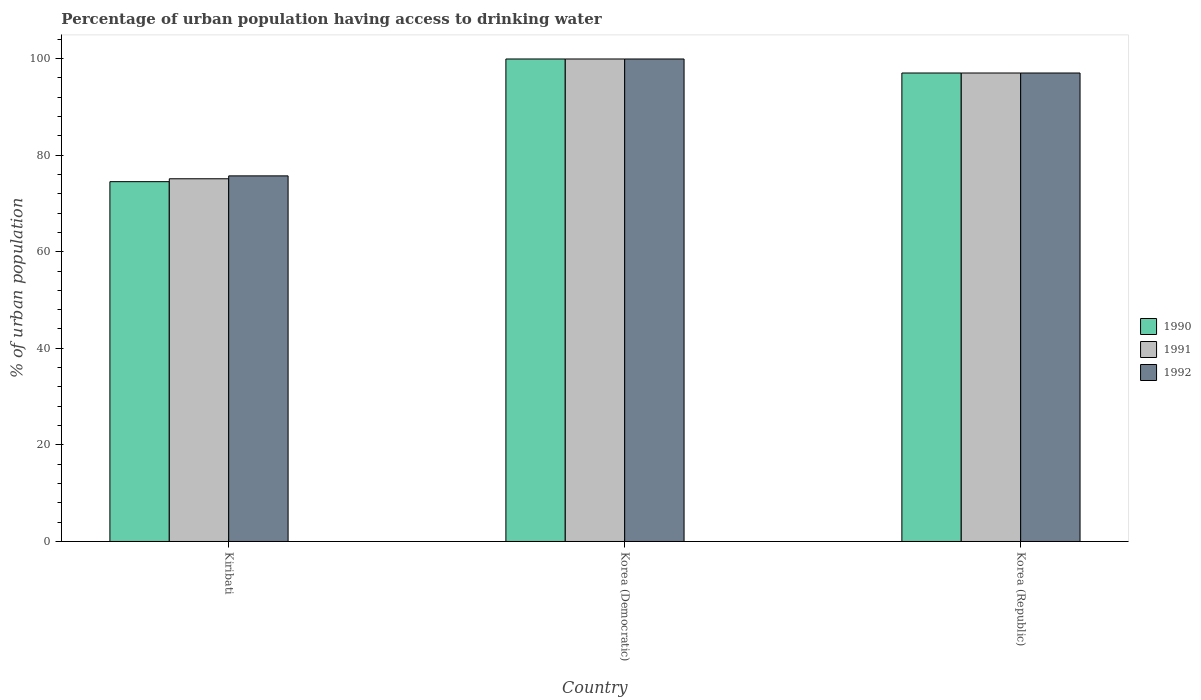How many different coloured bars are there?
Offer a very short reply. 3. How many groups of bars are there?
Keep it short and to the point. 3. Are the number of bars on each tick of the X-axis equal?
Your response must be concise. Yes. How many bars are there on the 1st tick from the left?
Make the answer very short. 3. How many bars are there on the 3rd tick from the right?
Offer a very short reply. 3. In how many cases, is the number of bars for a given country not equal to the number of legend labels?
Provide a succinct answer. 0. What is the percentage of urban population having access to drinking water in 1990 in Korea (Republic)?
Your answer should be compact. 97. Across all countries, what is the maximum percentage of urban population having access to drinking water in 1990?
Ensure brevity in your answer.  99.9. Across all countries, what is the minimum percentage of urban population having access to drinking water in 1990?
Make the answer very short. 74.5. In which country was the percentage of urban population having access to drinking water in 1992 maximum?
Your answer should be very brief. Korea (Democratic). In which country was the percentage of urban population having access to drinking water in 1991 minimum?
Keep it short and to the point. Kiribati. What is the total percentage of urban population having access to drinking water in 1992 in the graph?
Keep it short and to the point. 272.6. What is the difference between the percentage of urban population having access to drinking water in 1992 in Korea (Democratic) and that in Korea (Republic)?
Offer a terse response. 2.9. What is the difference between the percentage of urban population having access to drinking water in 1990 in Korea (Democratic) and the percentage of urban population having access to drinking water in 1991 in Korea (Republic)?
Provide a short and direct response. 2.9. What is the average percentage of urban population having access to drinking water in 1990 per country?
Provide a succinct answer. 90.47. What is the difference between the percentage of urban population having access to drinking water of/in 1991 and percentage of urban population having access to drinking water of/in 1990 in Korea (Republic)?
Ensure brevity in your answer.  0. What is the ratio of the percentage of urban population having access to drinking water in 1990 in Korea (Democratic) to that in Korea (Republic)?
Make the answer very short. 1.03. Is the percentage of urban population having access to drinking water in 1990 in Kiribati less than that in Korea (Democratic)?
Give a very brief answer. Yes. What is the difference between the highest and the second highest percentage of urban population having access to drinking water in 1990?
Offer a very short reply. 22.5. What is the difference between the highest and the lowest percentage of urban population having access to drinking water in 1991?
Your answer should be very brief. 24.8. In how many countries, is the percentage of urban population having access to drinking water in 1992 greater than the average percentage of urban population having access to drinking water in 1992 taken over all countries?
Offer a terse response. 2. Is the sum of the percentage of urban population having access to drinking water in 1990 in Kiribati and Korea (Democratic) greater than the maximum percentage of urban population having access to drinking water in 1992 across all countries?
Offer a terse response. Yes. Are all the bars in the graph horizontal?
Make the answer very short. No. How many countries are there in the graph?
Provide a succinct answer. 3. What is the difference between two consecutive major ticks on the Y-axis?
Your response must be concise. 20. Are the values on the major ticks of Y-axis written in scientific E-notation?
Ensure brevity in your answer.  No. How many legend labels are there?
Ensure brevity in your answer.  3. What is the title of the graph?
Keep it short and to the point. Percentage of urban population having access to drinking water. What is the label or title of the Y-axis?
Offer a terse response. % of urban population. What is the % of urban population of 1990 in Kiribati?
Provide a succinct answer. 74.5. What is the % of urban population of 1991 in Kiribati?
Offer a very short reply. 75.1. What is the % of urban population of 1992 in Kiribati?
Your answer should be very brief. 75.7. What is the % of urban population in 1990 in Korea (Democratic)?
Your response must be concise. 99.9. What is the % of urban population of 1991 in Korea (Democratic)?
Offer a very short reply. 99.9. What is the % of urban population in 1992 in Korea (Democratic)?
Provide a succinct answer. 99.9. What is the % of urban population in 1990 in Korea (Republic)?
Provide a short and direct response. 97. What is the % of urban population in 1991 in Korea (Republic)?
Make the answer very short. 97. What is the % of urban population of 1992 in Korea (Republic)?
Offer a very short reply. 97. Across all countries, what is the maximum % of urban population of 1990?
Provide a succinct answer. 99.9. Across all countries, what is the maximum % of urban population of 1991?
Provide a succinct answer. 99.9. Across all countries, what is the maximum % of urban population of 1992?
Make the answer very short. 99.9. Across all countries, what is the minimum % of urban population of 1990?
Your response must be concise. 74.5. Across all countries, what is the minimum % of urban population in 1991?
Keep it short and to the point. 75.1. Across all countries, what is the minimum % of urban population in 1992?
Offer a terse response. 75.7. What is the total % of urban population in 1990 in the graph?
Provide a succinct answer. 271.4. What is the total % of urban population in 1991 in the graph?
Your answer should be very brief. 272. What is the total % of urban population in 1992 in the graph?
Provide a succinct answer. 272.6. What is the difference between the % of urban population in 1990 in Kiribati and that in Korea (Democratic)?
Your response must be concise. -25.4. What is the difference between the % of urban population of 1991 in Kiribati and that in Korea (Democratic)?
Ensure brevity in your answer.  -24.8. What is the difference between the % of urban population of 1992 in Kiribati and that in Korea (Democratic)?
Your answer should be very brief. -24.2. What is the difference between the % of urban population in 1990 in Kiribati and that in Korea (Republic)?
Offer a terse response. -22.5. What is the difference between the % of urban population of 1991 in Kiribati and that in Korea (Republic)?
Ensure brevity in your answer.  -21.9. What is the difference between the % of urban population of 1992 in Kiribati and that in Korea (Republic)?
Give a very brief answer. -21.3. What is the difference between the % of urban population of 1990 in Korea (Democratic) and that in Korea (Republic)?
Ensure brevity in your answer.  2.9. What is the difference between the % of urban population in 1991 in Korea (Democratic) and that in Korea (Republic)?
Keep it short and to the point. 2.9. What is the difference between the % of urban population of 1990 in Kiribati and the % of urban population of 1991 in Korea (Democratic)?
Provide a succinct answer. -25.4. What is the difference between the % of urban population in 1990 in Kiribati and the % of urban population in 1992 in Korea (Democratic)?
Provide a succinct answer. -25.4. What is the difference between the % of urban population of 1991 in Kiribati and the % of urban population of 1992 in Korea (Democratic)?
Your answer should be very brief. -24.8. What is the difference between the % of urban population in 1990 in Kiribati and the % of urban population in 1991 in Korea (Republic)?
Your response must be concise. -22.5. What is the difference between the % of urban population in 1990 in Kiribati and the % of urban population in 1992 in Korea (Republic)?
Offer a terse response. -22.5. What is the difference between the % of urban population of 1991 in Kiribati and the % of urban population of 1992 in Korea (Republic)?
Give a very brief answer. -21.9. What is the average % of urban population in 1990 per country?
Your answer should be compact. 90.47. What is the average % of urban population in 1991 per country?
Offer a very short reply. 90.67. What is the average % of urban population of 1992 per country?
Your answer should be compact. 90.87. What is the difference between the % of urban population in 1990 and % of urban population in 1991 in Korea (Democratic)?
Make the answer very short. 0. What is the difference between the % of urban population of 1991 and % of urban population of 1992 in Korea (Democratic)?
Your response must be concise. 0. What is the difference between the % of urban population in 1990 and % of urban population in 1991 in Korea (Republic)?
Provide a succinct answer. 0. What is the difference between the % of urban population of 1991 and % of urban population of 1992 in Korea (Republic)?
Your response must be concise. 0. What is the ratio of the % of urban population of 1990 in Kiribati to that in Korea (Democratic)?
Make the answer very short. 0.75. What is the ratio of the % of urban population of 1991 in Kiribati to that in Korea (Democratic)?
Your response must be concise. 0.75. What is the ratio of the % of urban population in 1992 in Kiribati to that in Korea (Democratic)?
Offer a terse response. 0.76. What is the ratio of the % of urban population of 1990 in Kiribati to that in Korea (Republic)?
Offer a terse response. 0.77. What is the ratio of the % of urban population in 1991 in Kiribati to that in Korea (Republic)?
Your response must be concise. 0.77. What is the ratio of the % of urban population in 1992 in Kiribati to that in Korea (Republic)?
Offer a very short reply. 0.78. What is the ratio of the % of urban population of 1990 in Korea (Democratic) to that in Korea (Republic)?
Your answer should be very brief. 1.03. What is the ratio of the % of urban population of 1991 in Korea (Democratic) to that in Korea (Republic)?
Provide a short and direct response. 1.03. What is the ratio of the % of urban population of 1992 in Korea (Democratic) to that in Korea (Republic)?
Keep it short and to the point. 1.03. What is the difference between the highest and the second highest % of urban population in 1990?
Provide a succinct answer. 2.9. What is the difference between the highest and the second highest % of urban population of 1991?
Your answer should be compact. 2.9. What is the difference between the highest and the lowest % of urban population of 1990?
Your answer should be very brief. 25.4. What is the difference between the highest and the lowest % of urban population in 1991?
Provide a short and direct response. 24.8. What is the difference between the highest and the lowest % of urban population in 1992?
Provide a short and direct response. 24.2. 